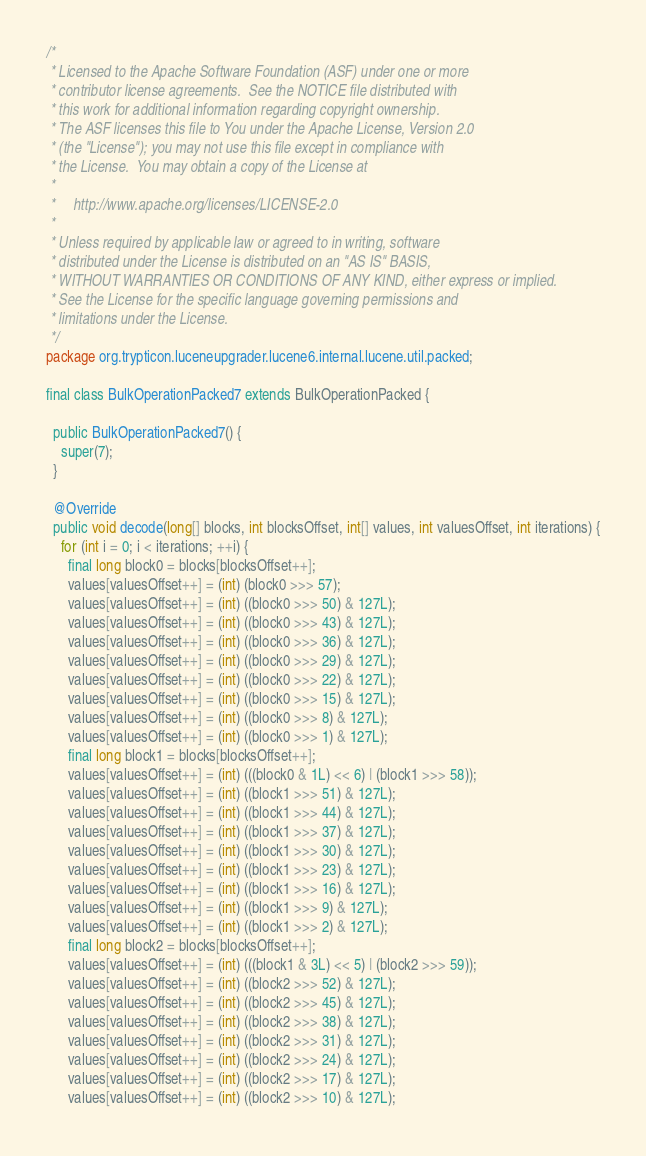Convert code to text. <code><loc_0><loc_0><loc_500><loc_500><_Java_>/*
 * Licensed to the Apache Software Foundation (ASF) under one or more
 * contributor license agreements.  See the NOTICE file distributed with
 * this work for additional information regarding copyright ownership.
 * The ASF licenses this file to You under the Apache License, Version 2.0
 * (the "License"); you may not use this file except in compliance with
 * the License.  You may obtain a copy of the License at
 *
 *     http://www.apache.org/licenses/LICENSE-2.0
 *
 * Unless required by applicable law or agreed to in writing, software
 * distributed under the License is distributed on an "AS IS" BASIS,
 * WITHOUT WARRANTIES OR CONDITIONS OF ANY KIND, either express or implied.
 * See the License for the specific language governing permissions and
 * limitations under the License.
 */
package org.trypticon.luceneupgrader.lucene6.internal.lucene.util.packed;

final class BulkOperationPacked7 extends BulkOperationPacked {

  public BulkOperationPacked7() {
    super(7);
  }

  @Override
  public void decode(long[] blocks, int blocksOffset, int[] values, int valuesOffset, int iterations) {
    for (int i = 0; i < iterations; ++i) {
      final long block0 = blocks[blocksOffset++];
      values[valuesOffset++] = (int) (block0 >>> 57);
      values[valuesOffset++] = (int) ((block0 >>> 50) & 127L);
      values[valuesOffset++] = (int) ((block0 >>> 43) & 127L);
      values[valuesOffset++] = (int) ((block0 >>> 36) & 127L);
      values[valuesOffset++] = (int) ((block0 >>> 29) & 127L);
      values[valuesOffset++] = (int) ((block0 >>> 22) & 127L);
      values[valuesOffset++] = (int) ((block0 >>> 15) & 127L);
      values[valuesOffset++] = (int) ((block0 >>> 8) & 127L);
      values[valuesOffset++] = (int) ((block0 >>> 1) & 127L);
      final long block1 = blocks[blocksOffset++];
      values[valuesOffset++] = (int) (((block0 & 1L) << 6) | (block1 >>> 58));
      values[valuesOffset++] = (int) ((block1 >>> 51) & 127L);
      values[valuesOffset++] = (int) ((block1 >>> 44) & 127L);
      values[valuesOffset++] = (int) ((block1 >>> 37) & 127L);
      values[valuesOffset++] = (int) ((block1 >>> 30) & 127L);
      values[valuesOffset++] = (int) ((block1 >>> 23) & 127L);
      values[valuesOffset++] = (int) ((block1 >>> 16) & 127L);
      values[valuesOffset++] = (int) ((block1 >>> 9) & 127L);
      values[valuesOffset++] = (int) ((block1 >>> 2) & 127L);
      final long block2 = blocks[blocksOffset++];
      values[valuesOffset++] = (int) (((block1 & 3L) << 5) | (block2 >>> 59));
      values[valuesOffset++] = (int) ((block2 >>> 52) & 127L);
      values[valuesOffset++] = (int) ((block2 >>> 45) & 127L);
      values[valuesOffset++] = (int) ((block2 >>> 38) & 127L);
      values[valuesOffset++] = (int) ((block2 >>> 31) & 127L);
      values[valuesOffset++] = (int) ((block2 >>> 24) & 127L);
      values[valuesOffset++] = (int) ((block2 >>> 17) & 127L);
      values[valuesOffset++] = (int) ((block2 >>> 10) & 127L);</code> 